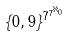Convert formula to latex. <formula><loc_0><loc_0><loc_500><loc_500>\{ 0 , 9 \} ^ { 7 ^ { 7 ^ { \aleph _ { 0 } } } }</formula> 